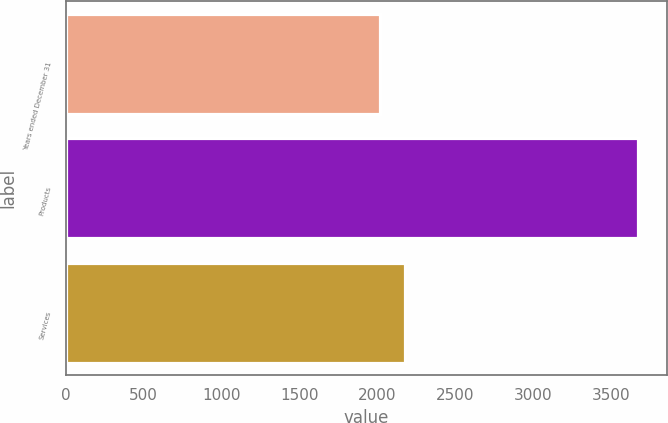Convert chart. <chart><loc_0><loc_0><loc_500><loc_500><bar_chart><fcel>Years ended December 31<fcel>Products<fcel>Services<nl><fcel>2015<fcel>3676<fcel>2181.1<nl></chart> 